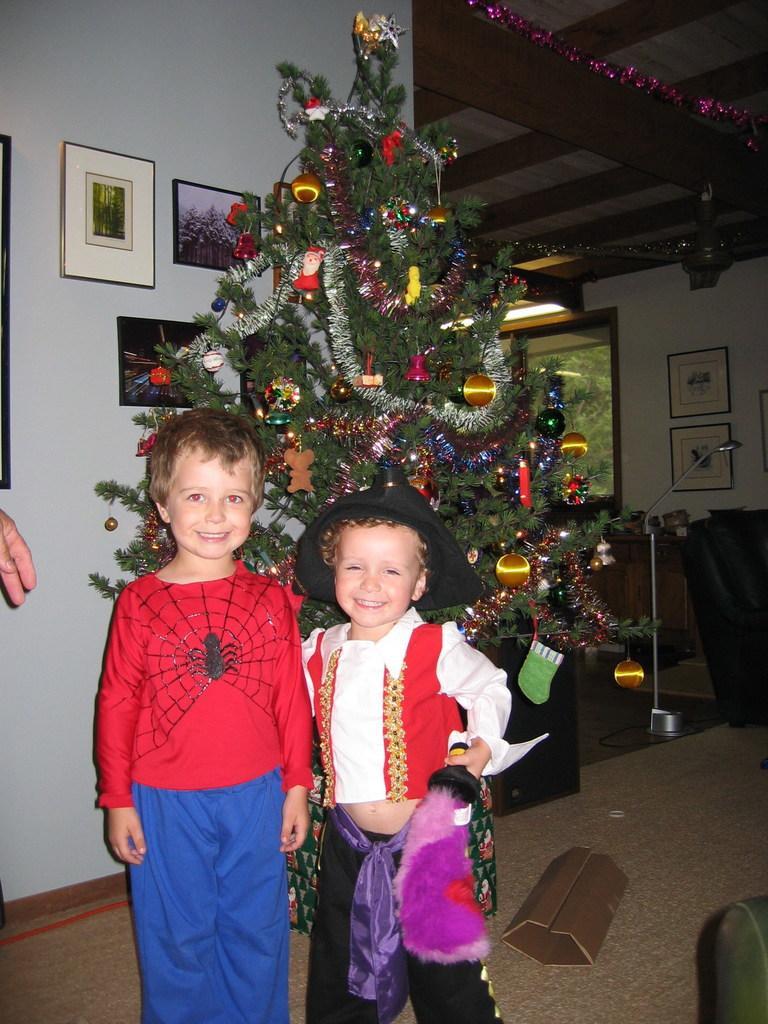In one or two sentences, can you explain what this image depicts? In the given picture, I can see two people towards right i can see a person holding an object in his hand and behind this people, I can see a Christmas tree which is decorated and wall, few images, and a floor, mat which is in brown color and i can see few object , fan, light. 